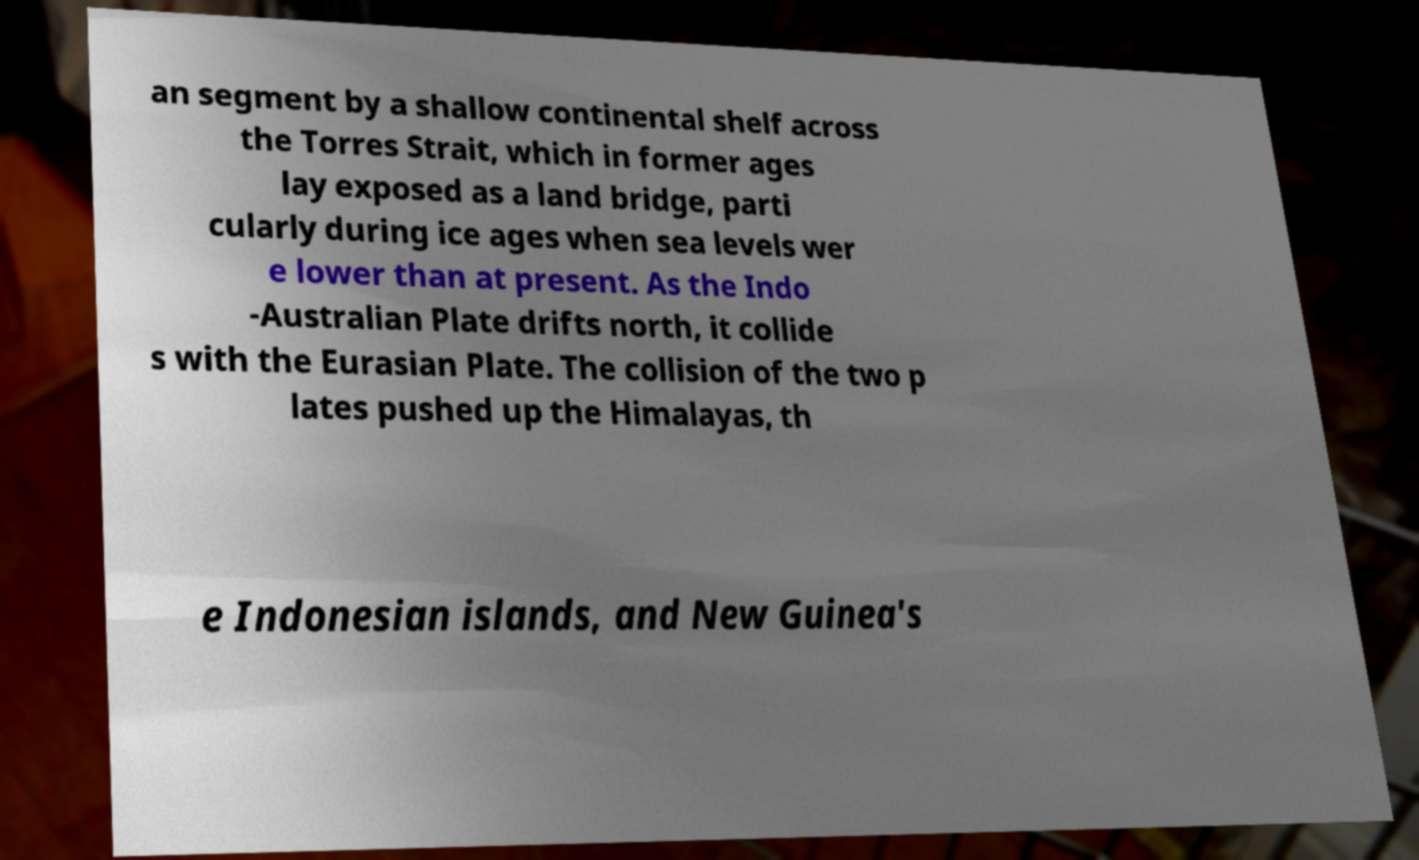Can you read and provide the text displayed in the image?This photo seems to have some interesting text. Can you extract and type it out for me? an segment by a shallow continental shelf across the Torres Strait, which in former ages lay exposed as a land bridge, parti cularly during ice ages when sea levels wer e lower than at present. As the Indo -Australian Plate drifts north, it collide s with the Eurasian Plate. The collision of the two p lates pushed up the Himalayas, th e Indonesian islands, and New Guinea's 